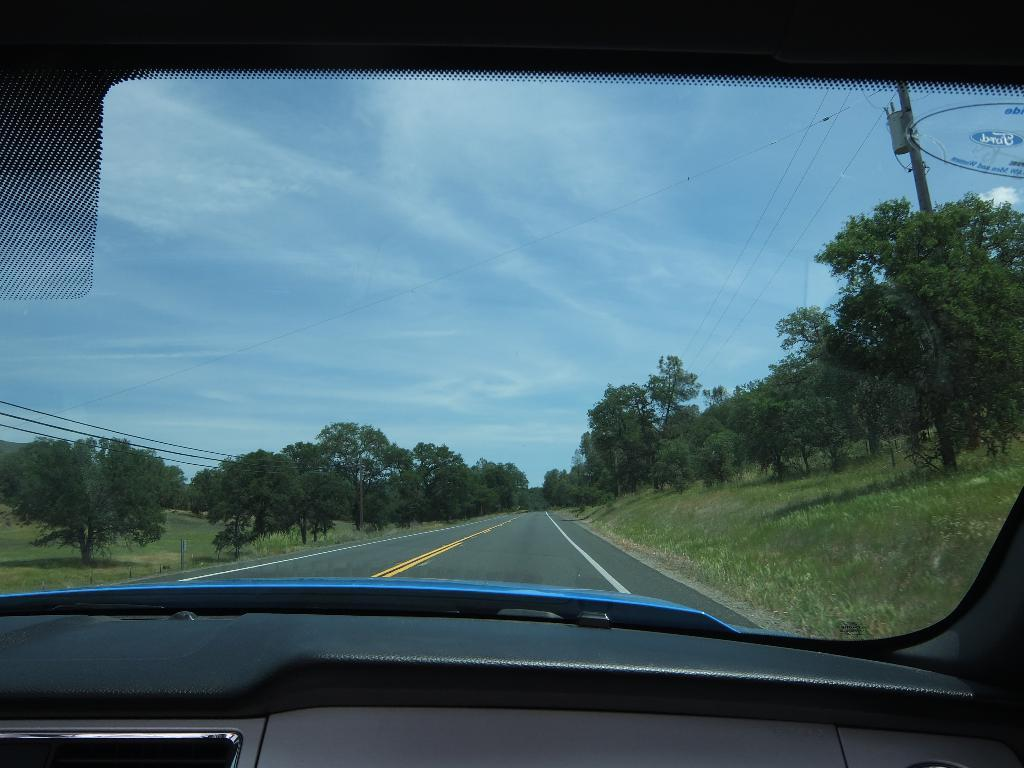What is the setting of the image? The image is from the dashboard of a car. What can be seen through the windshield of the car? There is a road visible in the image. What type of vegetation is present on either side of the road? There are trees on either side of the road. What else can be seen in the sky or at the top of the image? Electrical cables are present on poles at the top of the image. What type of rice is being cooked in the image? There is no rice present in the image; it is a view from the dashboard of a car. Can you see a guitar in the image? There is no guitar present in the image. 